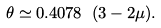Convert formula to latex. <formula><loc_0><loc_0><loc_500><loc_500>\theta \simeq 0 . 4 0 7 8 \ ( 3 - 2 \mu ) .</formula> 